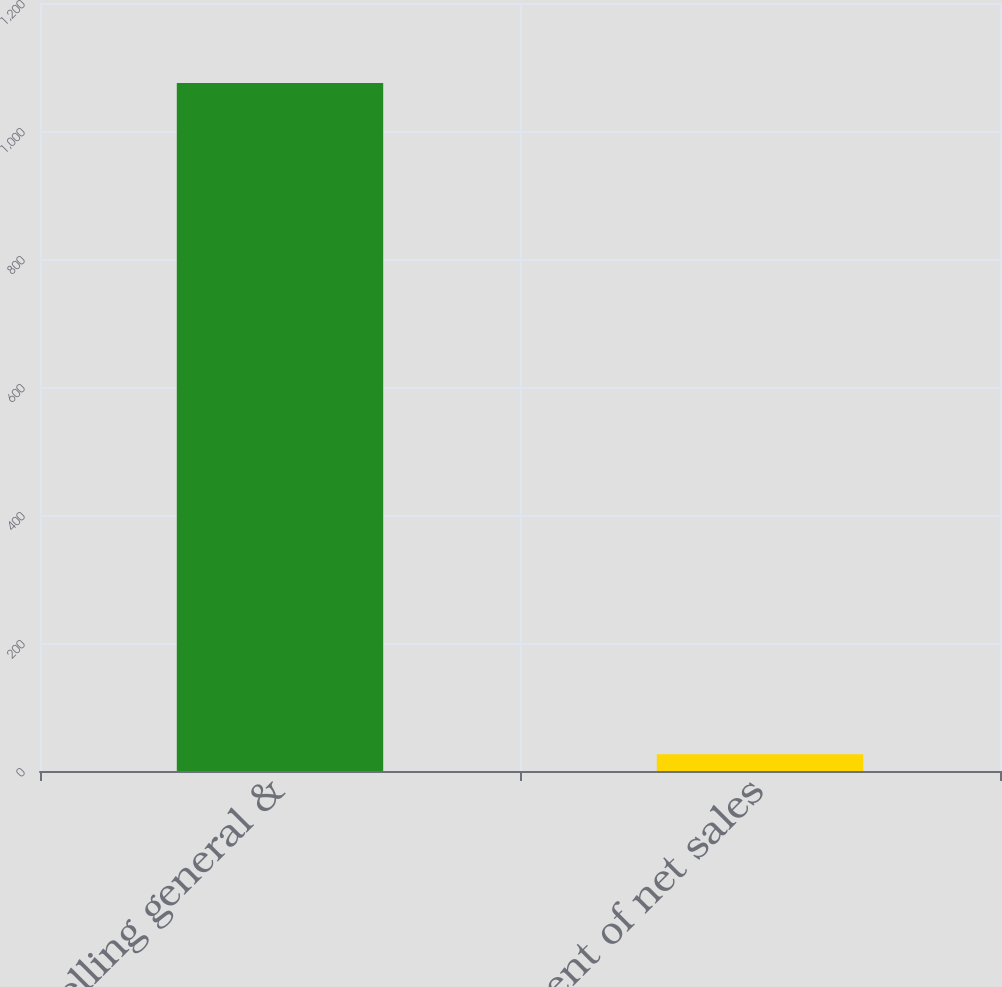<chart> <loc_0><loc_0><loc_500><loc_500><bar_chart><fcel>Selling general &<fcel>Percent of net sales<nl><fcel>1075<fcel>26.1<nl></chart> 